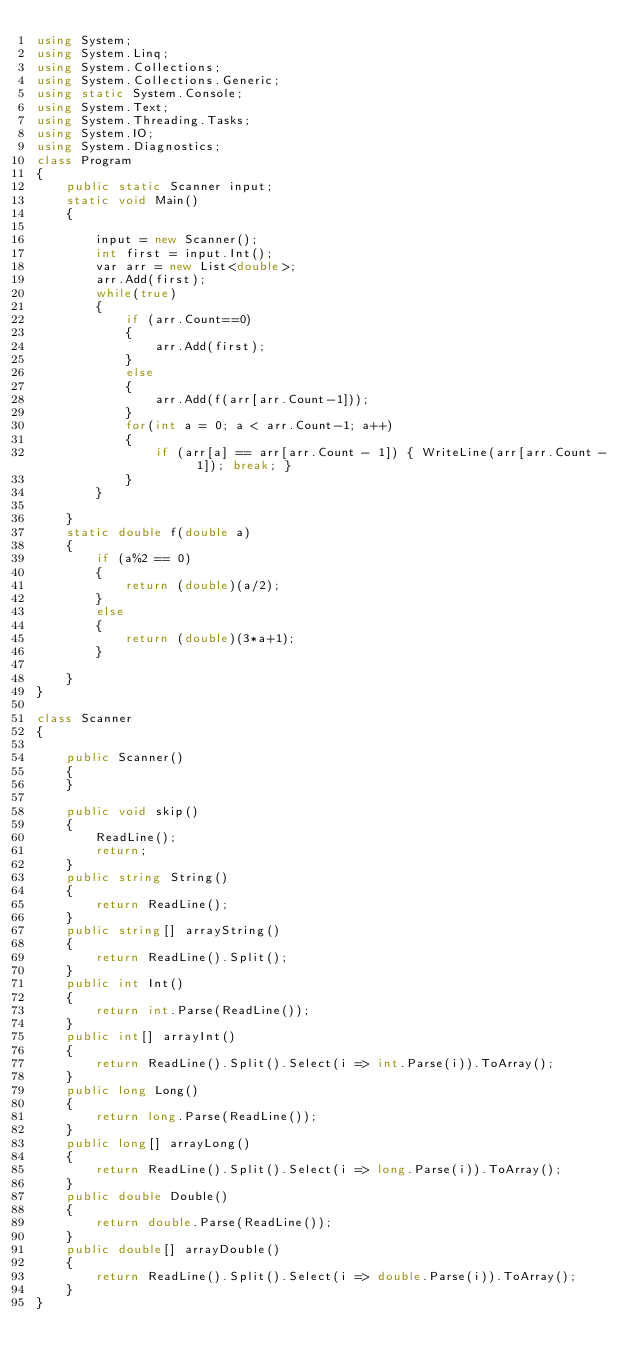Convert code to text. <code><loc_0><loc_0><loc_500><loc_500><_C#_>using System;
using System.Linq;
using System.Collections;
using System.Collections.Generic;
using static System.Console;
using System.Text;
using System.Threading.Tasks;
using System.IO;
using System.Diagnostics;
class Program
{
    public static Scanner input;
    static void Main()
    {

        input = new Scanner();
        int first = input.Int();
        var arr = new List<double>;
        arr.Add(first);
        while(true)
        {
            if (arr.Count==0)
            {
                arr.Add(first);
            }
            else
            {
                arr.Add(f(arr[arr.Count-1]));
            }
            for(int a = 0; a < arr.Count-1; a++)
            {
                if (arr[a] == arr[arr.Count - 1]) { WriteLine(arr[arr.Count - 1]); break; }
            }
        }

    }
    static double f(double a)
    {
        if (a%2 == 0)
        {
            return (double)(a/2);
        }
        else
        {
            return (double)(3*a+1);
        }

    }
}

class Scanner
{

    public Scanner()
    {
    }

    public void skip()
    {
        ReadLine();
        return;
    }
    public string String()
    {
        return ReadLine();
    }
    public string[] arrayString()
    {
        return ReadLine().Split();
    }
    public int Int()
    {
        return int.Parse(ReadLine());
    }
    public int[] arrayInt()
    {
        return ReadLine().Split().Select(i => int.Parse(i)).ToArray();
    }
    public long Long()
    {
        return long.Parse(ReadLine());
    }
    public long[] arrayLong()
    {
        return ReadLine().Split().Select(i => long.Parse(i)).ToArray();
    }
    public double Double()
    {
        return double.Parse(ReadLine());
    }
    public double[] arrayDouble()
    {
        return ReadLine().Split().Select(i => double.Parse(i)).ToArray();
    }
}</code> 